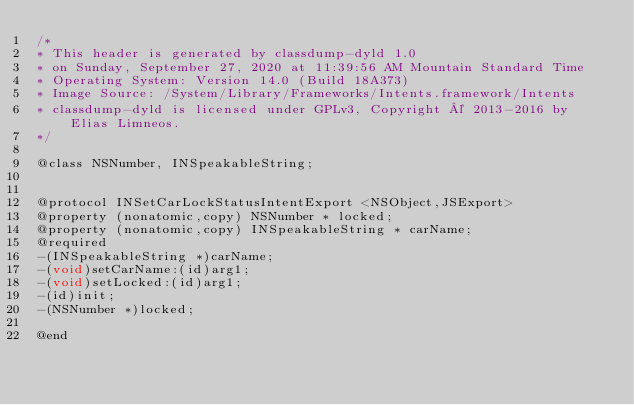Convert code to text. <code><loc_0><loc_0><loc_500><loc_500><_C_>/*
* This header is generated by classdump-dyld 1.0
* on Sunday, September 27, 2020 at 11:39:56 AM Mountain Standard Time
* Operating System: Version 14.0 (Build 18A373)
* Image Source: /System/Library/Frameworks/Intents.framework/Intents
* classdump-dyld is licensed under GPLv3, Copyright © 2013-2016 by Elias Limneos.
*/

@class NSNumber, INSpeakableString;


@protocol INSetCarLockStatusIntentExport <NSObject,JSExport>
@property (nonatomic,copy) NSNumber * locked; 
@property (nonatomic,copy) INSpeakableString * carName; 
@required
-(INSpeakableString *)carName;
-(void)setCarName:(id)arg1;
-(void)setLocked:(id)arg1;
-(id)init;
-(NSNumber *)locked;

@end

</code> 